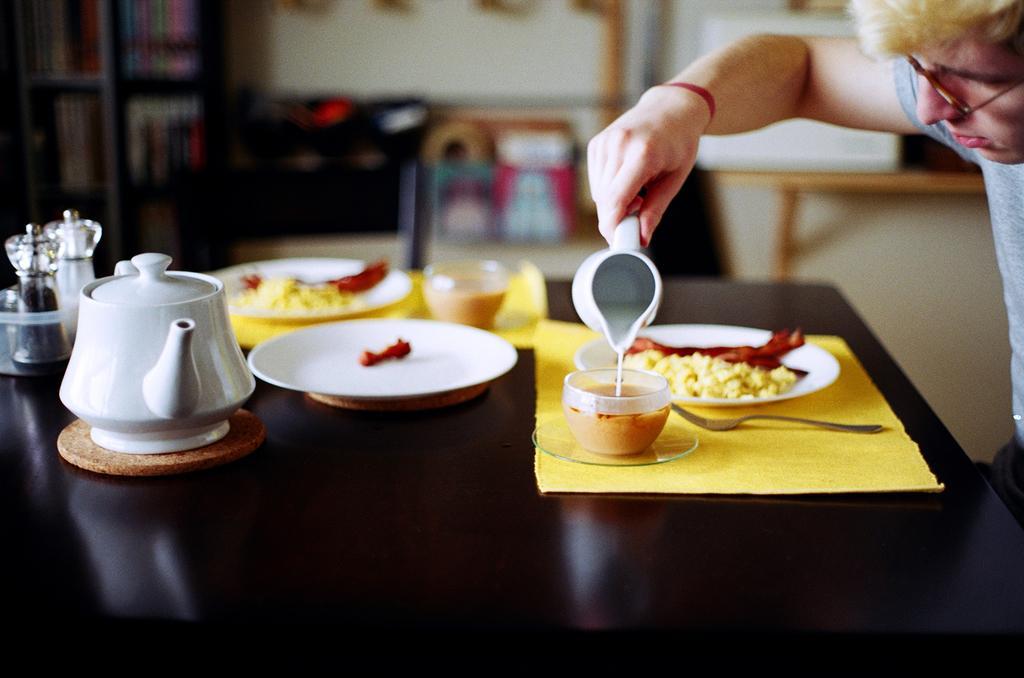How would you summarize this image in a sentence or two? We can see jars,kettle,plates,food,cups,mat,spoon on the table. This person holding cup. On the background we can see wall. 